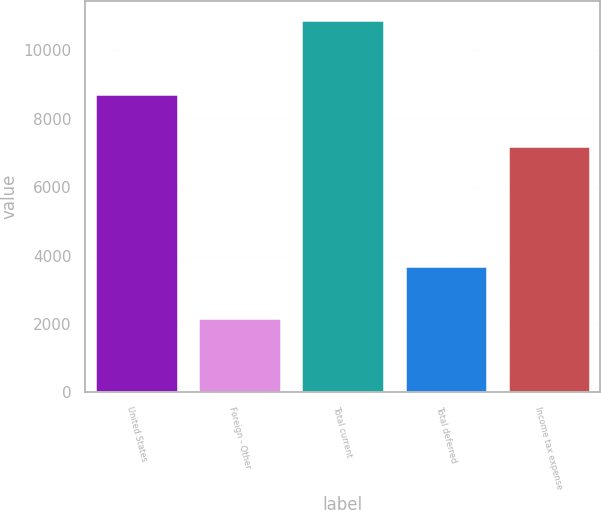Convert chart. <chart><loc_0><loc_0><loc_500><loc_500><bar_chart><fcel>United States<fcel>Foreign - Other<fcel>Total current<fcel>Total deferred<fcel>Income tax expense<nl><fcel>8736<fcel>2166<fcel>10902<fcel>3684<fcel>7218<nl></chart> 